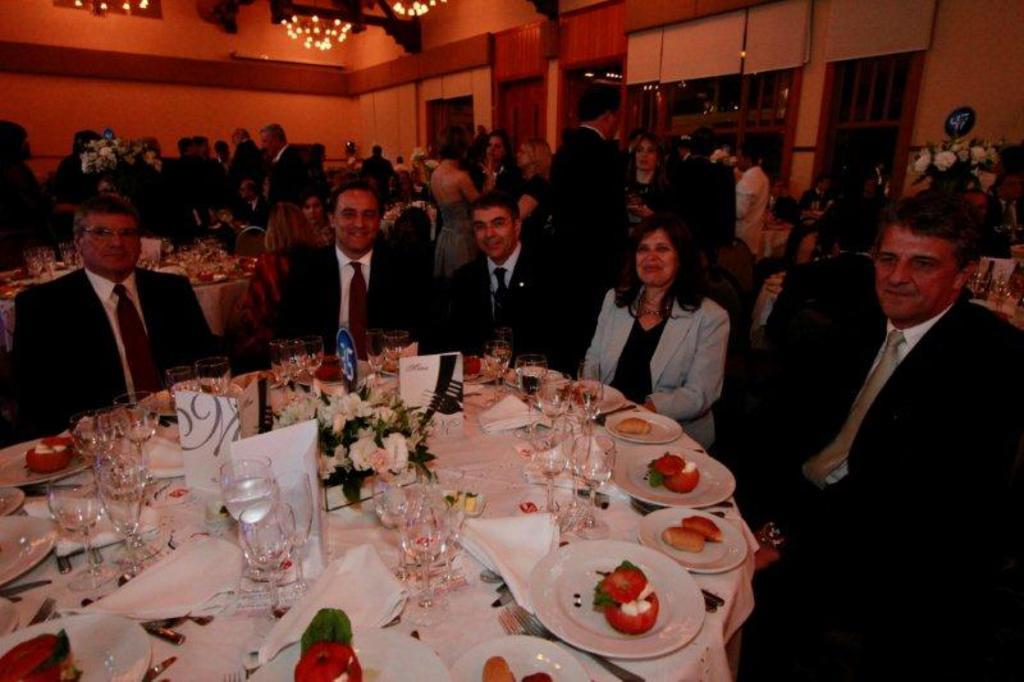Can you describe this image briefly? There is a group of people. Some people are sitting in a chair and some people are standing. There is a table. There is a glass,tissue,plate ,strawberry and food items on a table. We can see in the background there is a flower vase,lights and cupboards. 